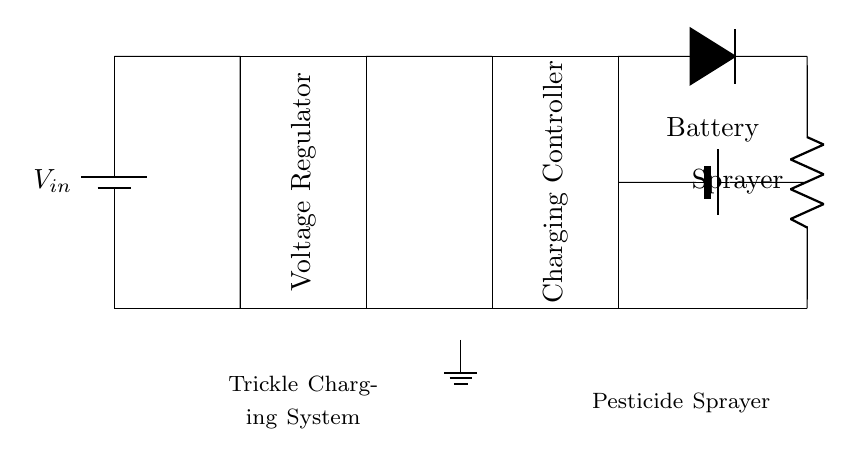What is the main function of the diode in this circuit? The diode provides reverse current protection, ensuring that current cannot flow back into the charging system from the load. This prevents potential damage to the components.
Answer: Reverse current protection What component regulates the voltage in the circuit? The voltage regulator is responsible for maintaining a consistent output voltage despite variations in input voltage or load conditions.
Answer: Voltage regulator How is the battery connected in the circuit? The battery is connected in parallel with the load to provide power during operation. The circuit allows charging while the battery is not in use.
Answer: In parallel What does the charging controller do? The charging controller manages the charging process to ensure the battery is charged safely and efficiently, preventing overcharging or deep discharge.
Answer: Manages charging What is the purpose of trickle charging in this system? Trickle charging ensures the battery maintains a full charge over extended periods of inactivity, avoiding deep discharge and prolonging battery life.
Answer: Maintains charge What load is being powered in this circuit? The circuit is designed to power a pesticide sprayer, which is the load represented in the diagram.
Answer: Pesticide sprayer How many components are primarily used in the circuit? There are five primary components: a battery, a voltage regulator, a charging controller, a diode, and a load (the sprayer).
Answer: Five components 